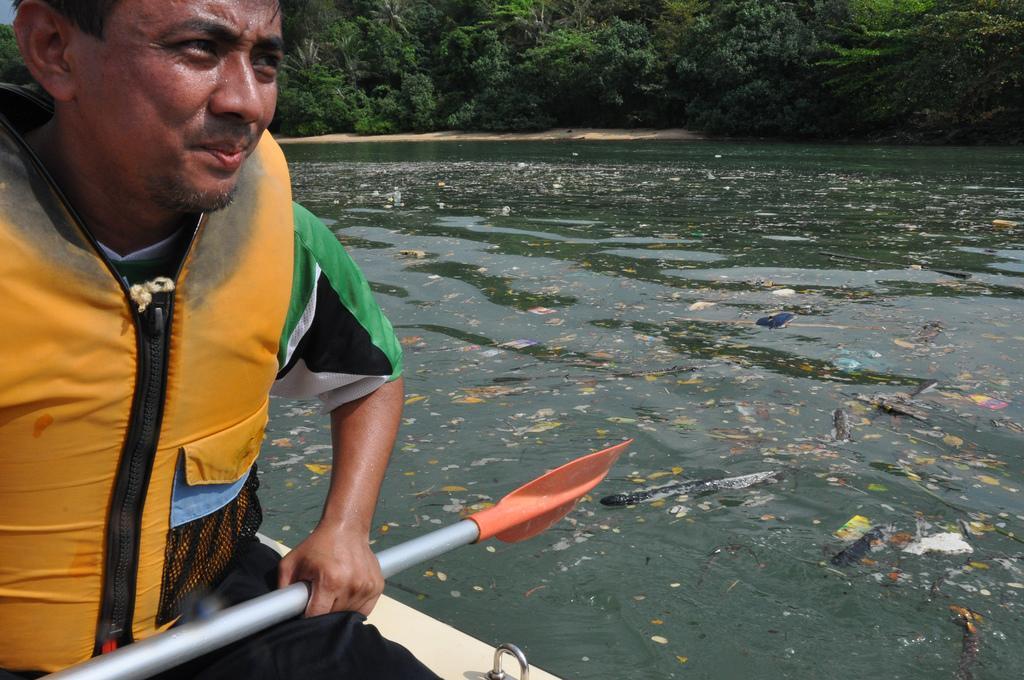Can you describe this image briefly? In this image there is a person wearing a jacket. He is sitting on the boat. He is holding a raft. There is some trash on the surface of the water. Background there are trees on the land. 